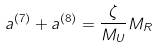<formula> <loc_0><loc_0><loc_500><loc_500>a ^ { ( 7 ) } + a ^ { ( 8 ) } = \frac { \zeta } { M _ { U } } M _ { R }</formula> 